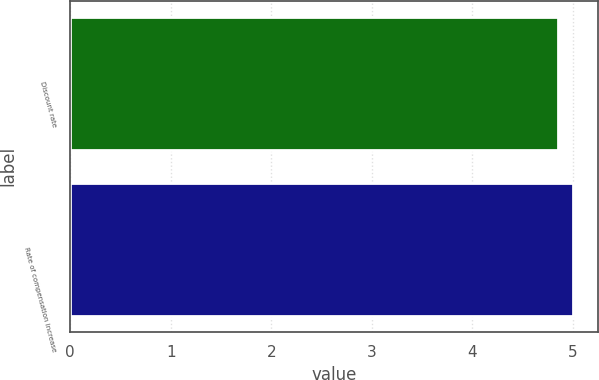Convert chart to OTSL. <chart><loc_0><loc_0><loc_500><loc_500><bar_chart><fcel>Discount rate<fcel>Rate of compensation increase<nl><fcel>4.85<fcel>5<nl></chart> 